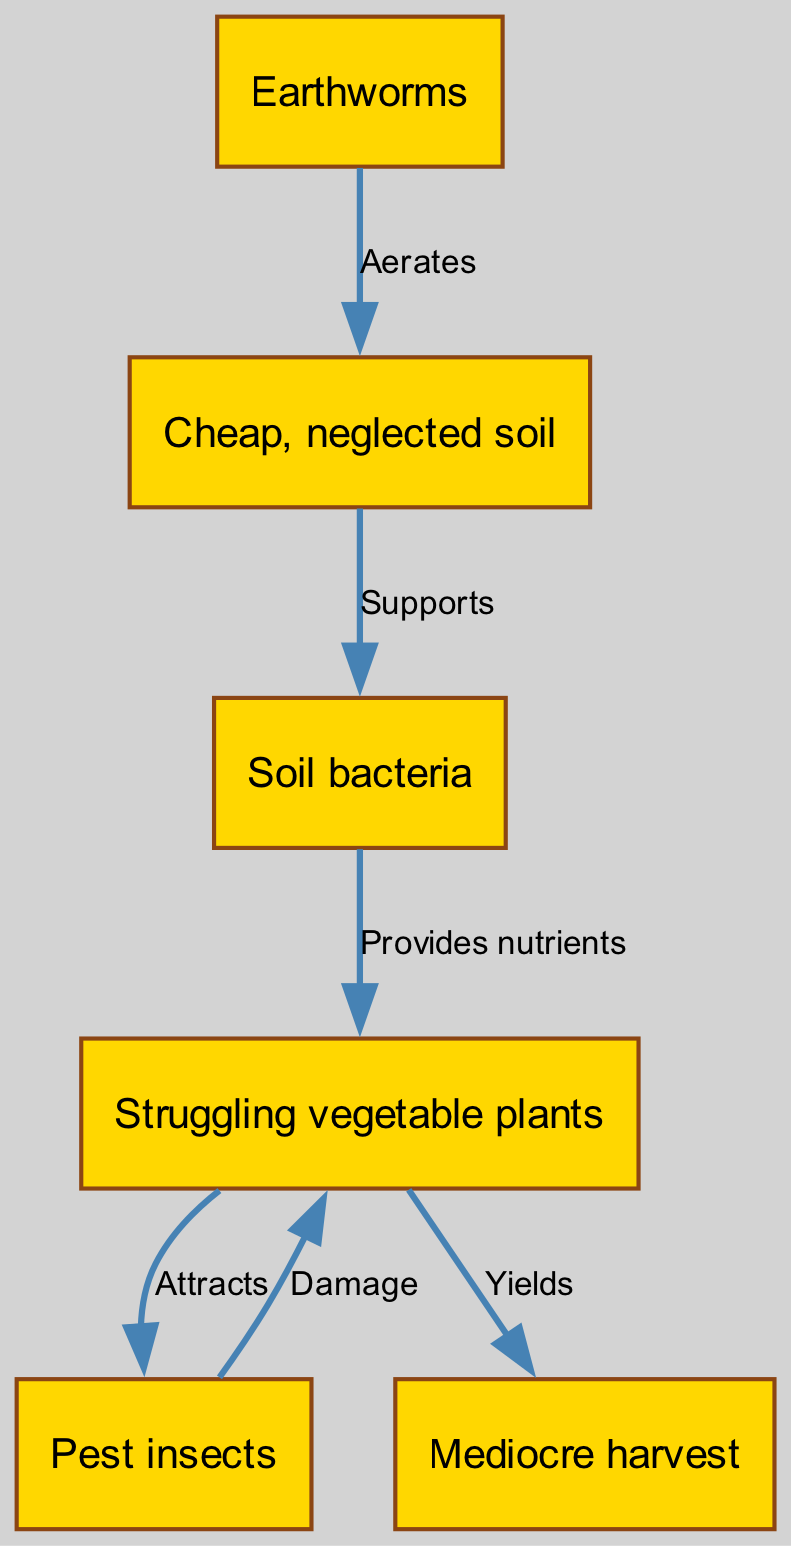What is the label of the first node in the diagram? The first node in the diagram is labeled "Cheap, neglected soil." This is confirmed by locating the node at the top of the diagram.
Answer: Cheap, neglected soil How many nodes are present in the diagram? By counting all the distinct nodes listed in the data, we find there are a total of six nodes: soil, bacteria, worms, plants, insects, and harvest.
Answer: 6 What relationship does soil have with bacteria? The relationship between soil and bacteria is defined by the label "Supports," indicating that soil provides support to bacteria. This can be identified by tracing the edge from soil to bacteria.
Answer: Supports Which node yields the harvest? The node that yields the harvest is "Struggling vegetable plants," as indicated by the label "Yields" that connects plants to harvest. This shows that plants are the source of the harvest.
Answer: Struggling vegetable plants What damage do pests cause? The pests, represented by the node "Pest insects," cause "Damage" to the plants. This is evident by the edge labeled "Damage" connecting insects to plants.
Answer: Damage How do earthworms interact with soil? Earthworms "Aerate" the soil, as shown by the edge labeled "Aerates" that connects the worms to the soil node. This interaction indicates that earthworms help improve the soil structure.
Answer: Aerates What impact do plants have on insect populations? The plants "Attract" insects, as indicated by the edge labeled "Attracts" that connects the plants to the insect node. This shows a positive relationship where plants bring insects into the ecosystem.
Answer: Attracts What nutrient source do bacteria provide? Soil bacteria provide "nutrients" to the plants, as indicated by the edge labeled "Provides nutrients" that connects the bacteria node to the plants node. This shows that bacteria are essential for plant nutrition.
Answer: Provides nutrients What is the end product of this food chain? The end product of this food chain is "Mediocre harvest," which is the final node in the diagram. It is reached through the relationships established by the previous nodes and edges.
Answer: Mediocre harvest 